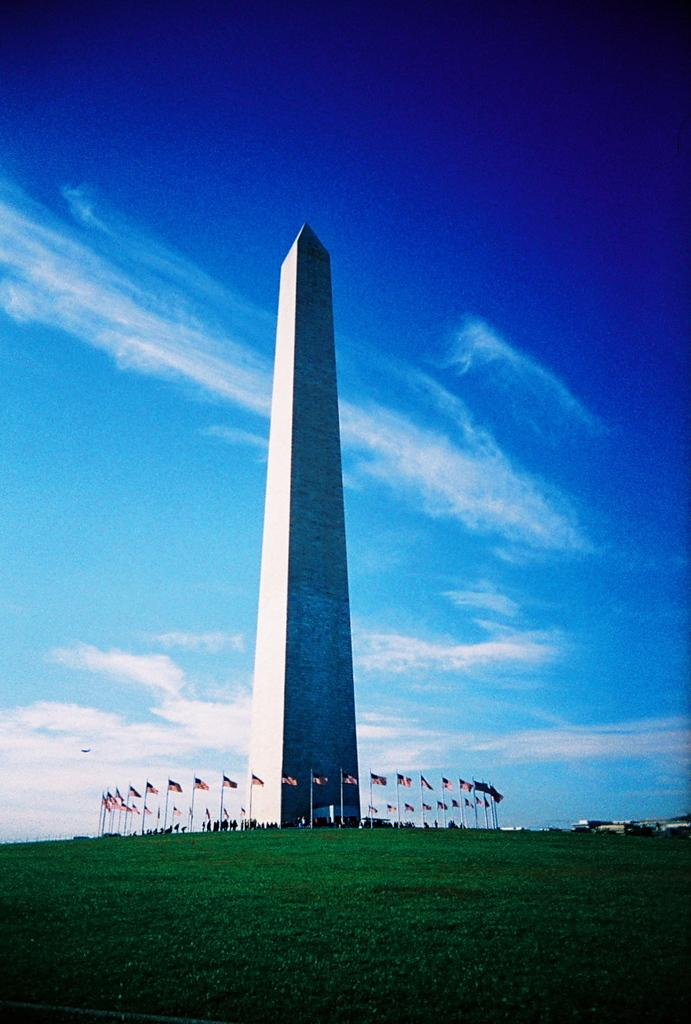What is the main subject in the center of the image? There is a memorial in the center of the image. What can be seen surrounding the memorial? There are flags around the memorial. What type of vegetation is present at the bottom of the image? Grass is present at the bottom of the image. What is visible in the background of the image? The sky is visible in the background of the image. How many dogs are wearing stockings in the image? There are no dogs or stockings present in the image. 